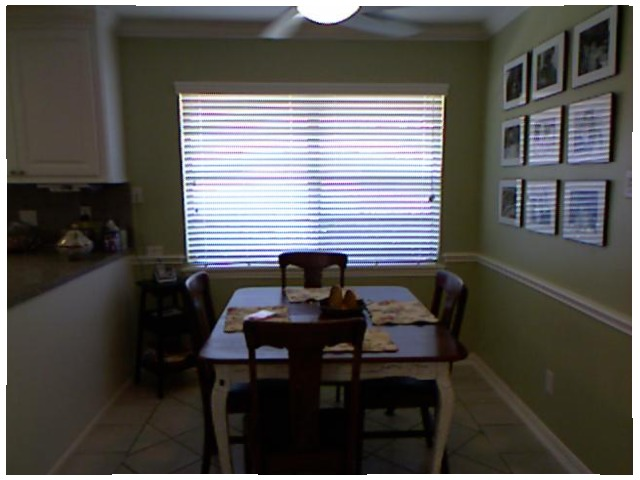<image>
Can you confirm if the chair is on the table? No. The chair is not positioned on the table. They may be near each other, but the chair is not supported by or resting on top of the table. Is there a picture on the wall? No. The picture is not positioned on the wall. They may be near each other, but the picture is not supported by or resting on top of the wall. Where is the blinds in relation to the window? Is it behind the window? No. The blinds is not behind the window. From this viewpoint, the blinds appears to be positioned elsewhere in the scene. 